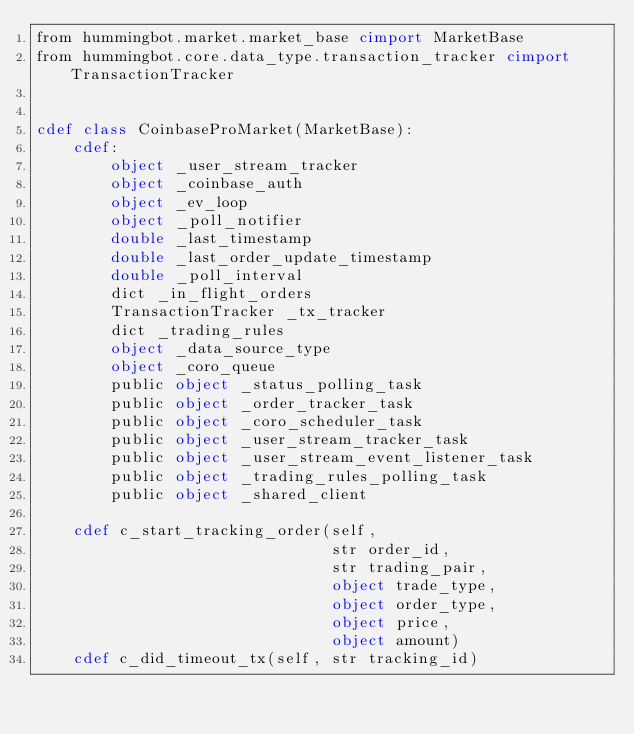Convert code to text. <code><loc_0><loc_0><loc_500><loc_500><_Cython_>from hummingbot.market.market_base cimport MarketBase
from hummingbot.core.data_type.transaction_tracker cimport TransactionTracker


cdef class CoinbaseProMarket(MarketBase):
    cdef:
        object _user_stream_tracker
        object _coinbase_auth
        object _ev_loop
        object _poll_notifier
        double _last_timestamp
        double _last_order_update_timestamp
        double _poll_interval
        dict _in_flight_orders
        TransactionTracker _tx_tracker
        dict _trading_rules
        object _data_source_type
        object _coro_queue
        public object _status_polling_task
        public object _order_tracker_task
        public object _coro_scheduler_task
        public object _user_stream_tracker_task
        public object _user_stream_event_listener_task
        public object _trading_rules_polling_task
        public object _shared_client

    cdef c_start_tracking_order(self,
                                str order_id,
                                str trading_pair,
                                object trade_type,
                                object order_type,
                                object price,
                                object amount)
    cdef c_did_timeout_tx(self, str tracking_id)
</code> 